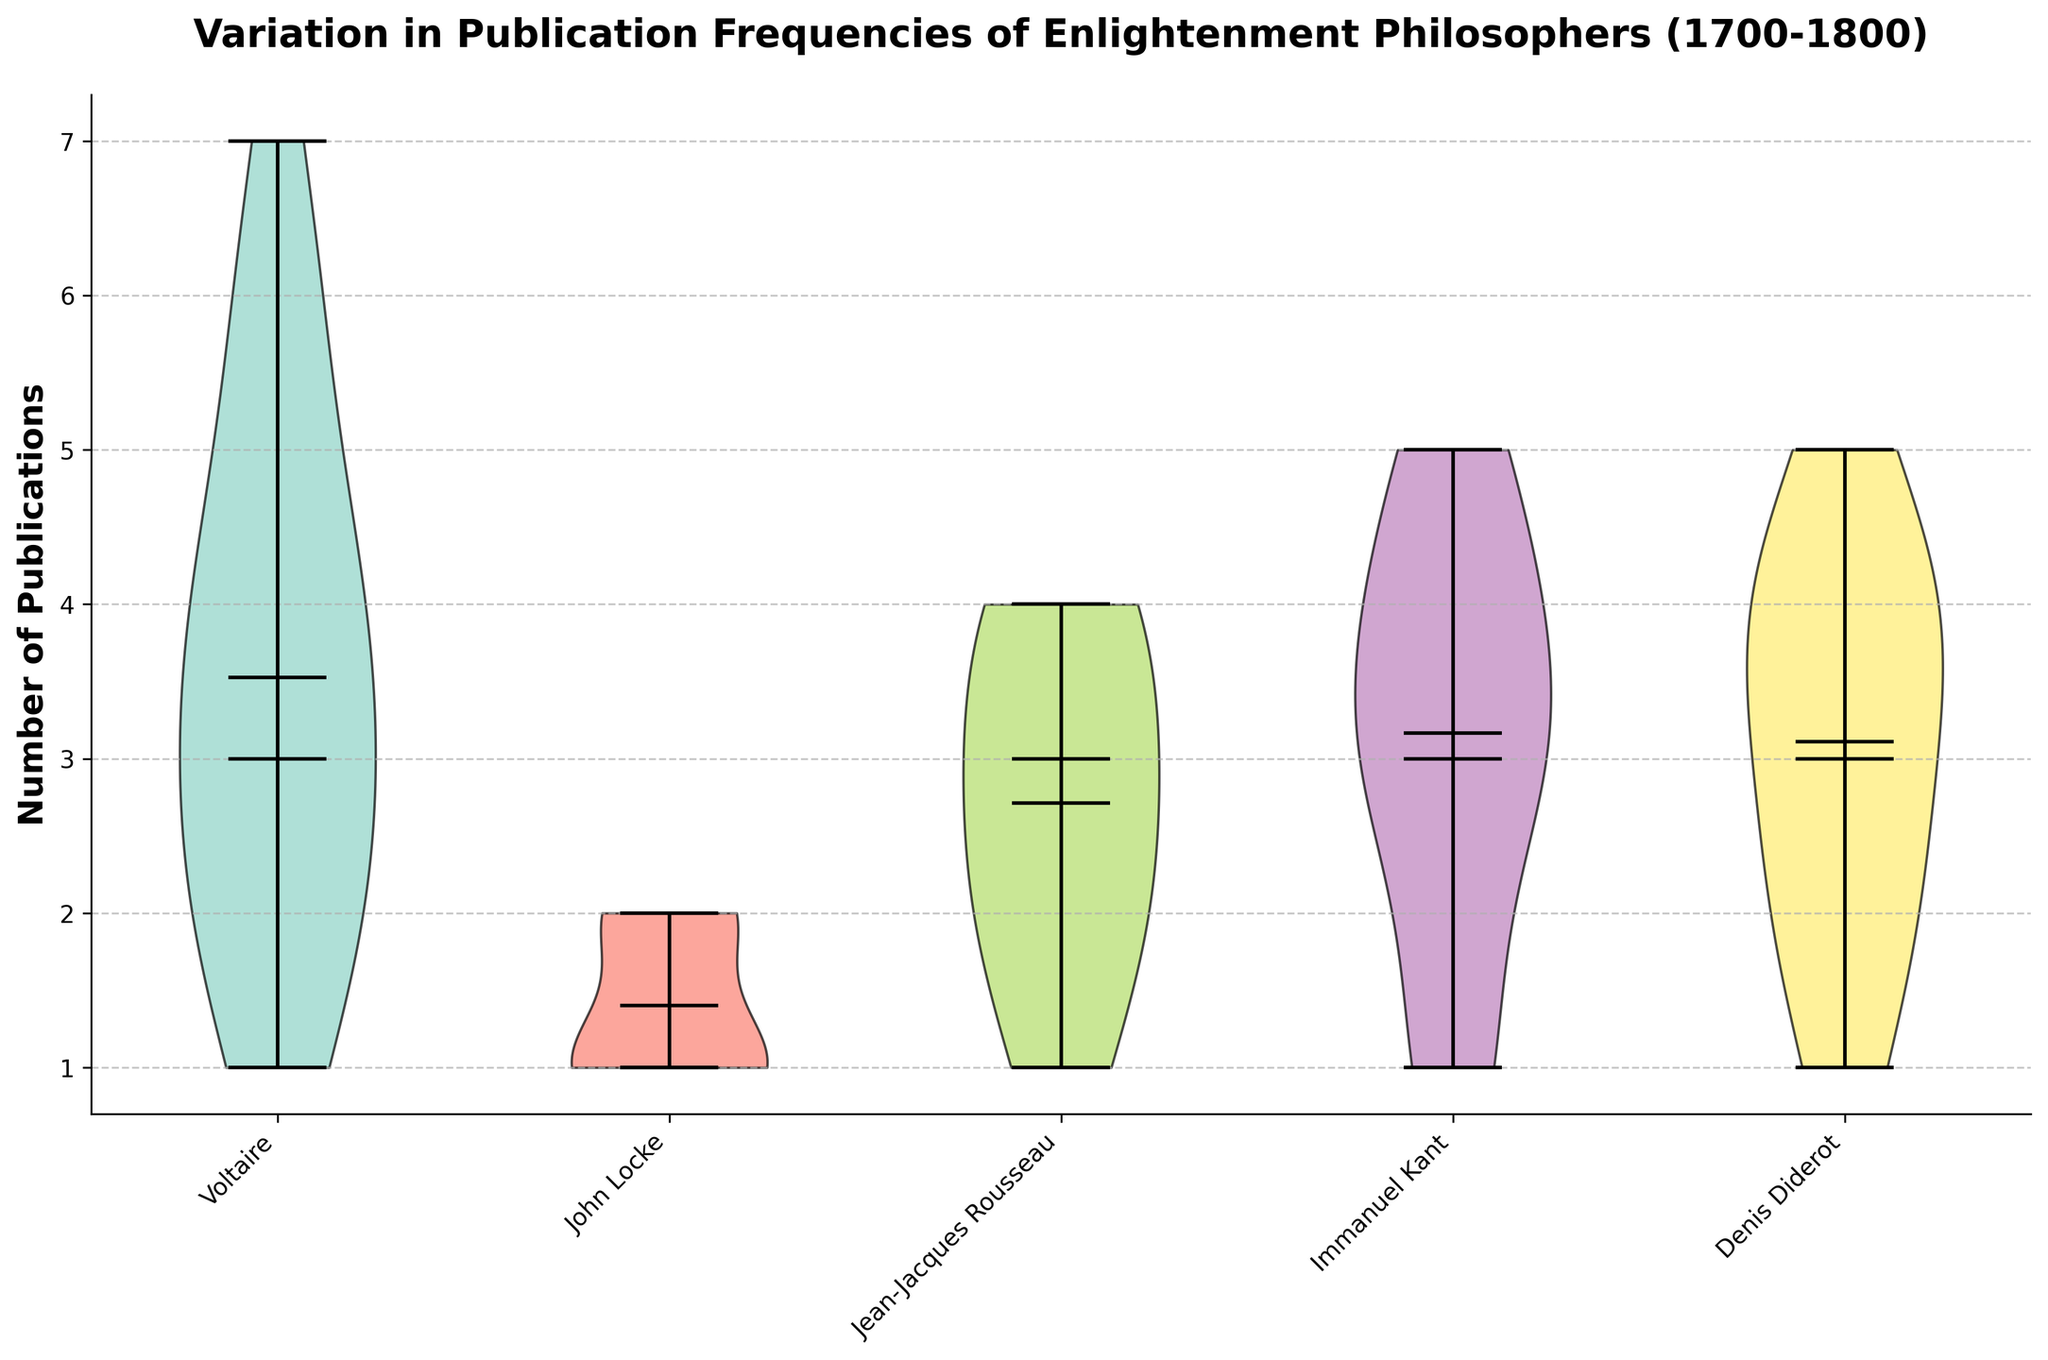What is the title of the figure? The title of the figure is typically located at the top, in a larger font size. It summarises the main subject of the visual representation.
Answer: Variation in Publication Frequencies of Enlightenment Philosophers (1700-1800) How are the philosophers represented in the figure? The philosophers are represented by different violins in a violin plot, each labeled on the x-axis with the names of the philosophers.
Answer: Different violins along the x-axis Which philosopher shows the widest spread of publication frequencies? To determine this, we need to look at the violin plot with the largest width, indicating a wide distribution.
Answer: Voltaire Which philosopher has the highest median number of publications? The highest median value is indicated by the middle horizontal line in each violin plot. The philosopher with the highest median publication line is the one with the highest value.
Answer: Immanuel Kant What is the range of publications for Voltaire? The minimum and maximum points on the violin plot for Voltaire show the range of his publications. Voltaire's plot includes all values from his lowest to highest number of publications.
Answer: 1 to 7 Which philosopher shows the lowest variability in publication frequencies? The philosopher with the narrowest violin plot indicates less variability in their publication frequencies.
Answer: John Locke Which philosopher's publications show an increasing trend over time? By carefully examining the plot and the placements of the means (indicated by the small marker within each violin) over time, one can identify the trend.
Answer: Immanuel Kant Who had more publications on average, Voltaire or Rousseau? By comparing the mean values (marked by dots within the violins) for the two philosophers, we can identify who had more average publications.
Answer: Voltaire What does the shape of the violin plot signify about the distribution of publications for Immanuel Kant? The shape of the violin plot indicates the density of the publication frequencies at different values, with wider sections representing more frequent values.
Answer: The majority of Kant's publications are concentrated around the higher values 